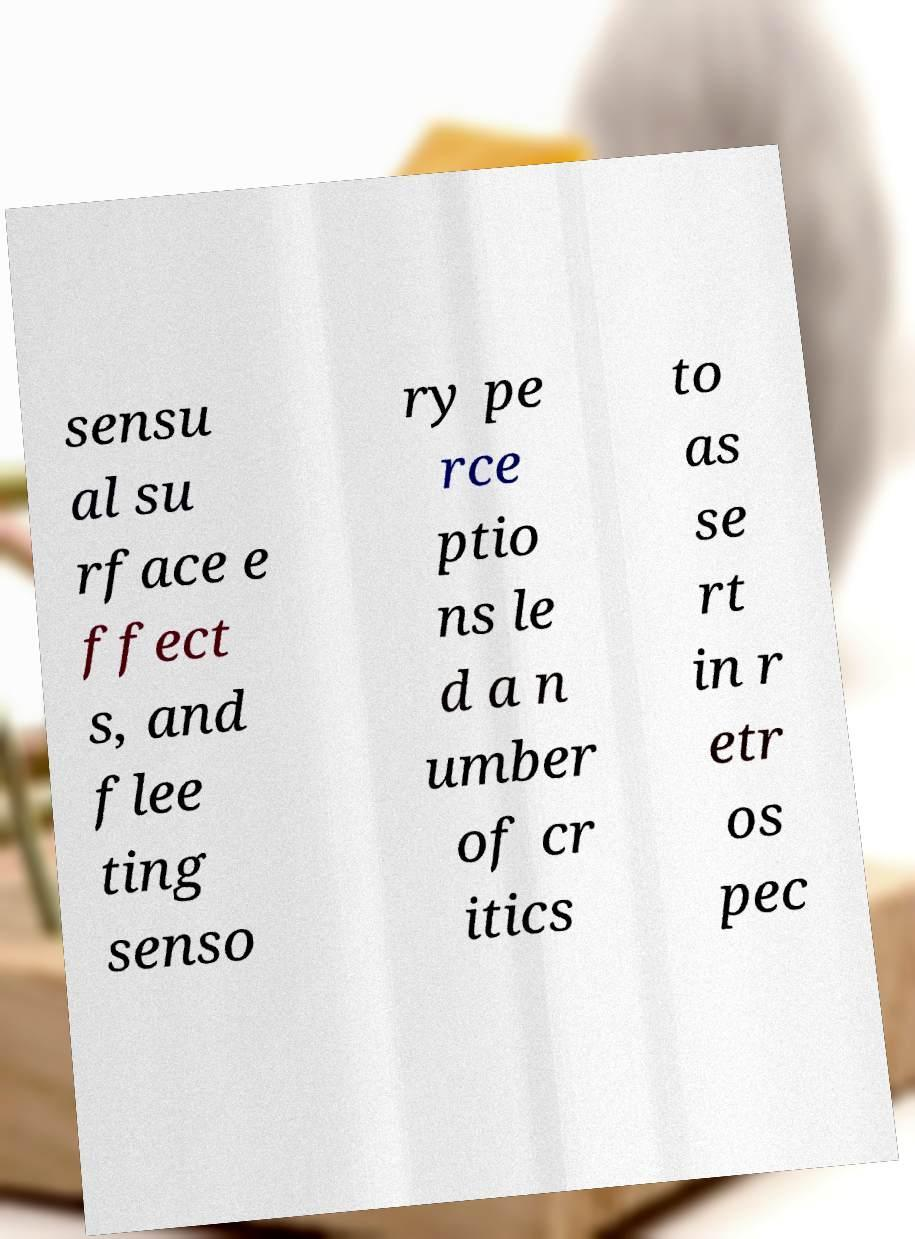Please identify and transcribe the text found in this image. sensu al su rface e ffect s, and flee ting senso ry pe rce ptio ns le d a n umber of cr itics to as se rt in r etr os pec 